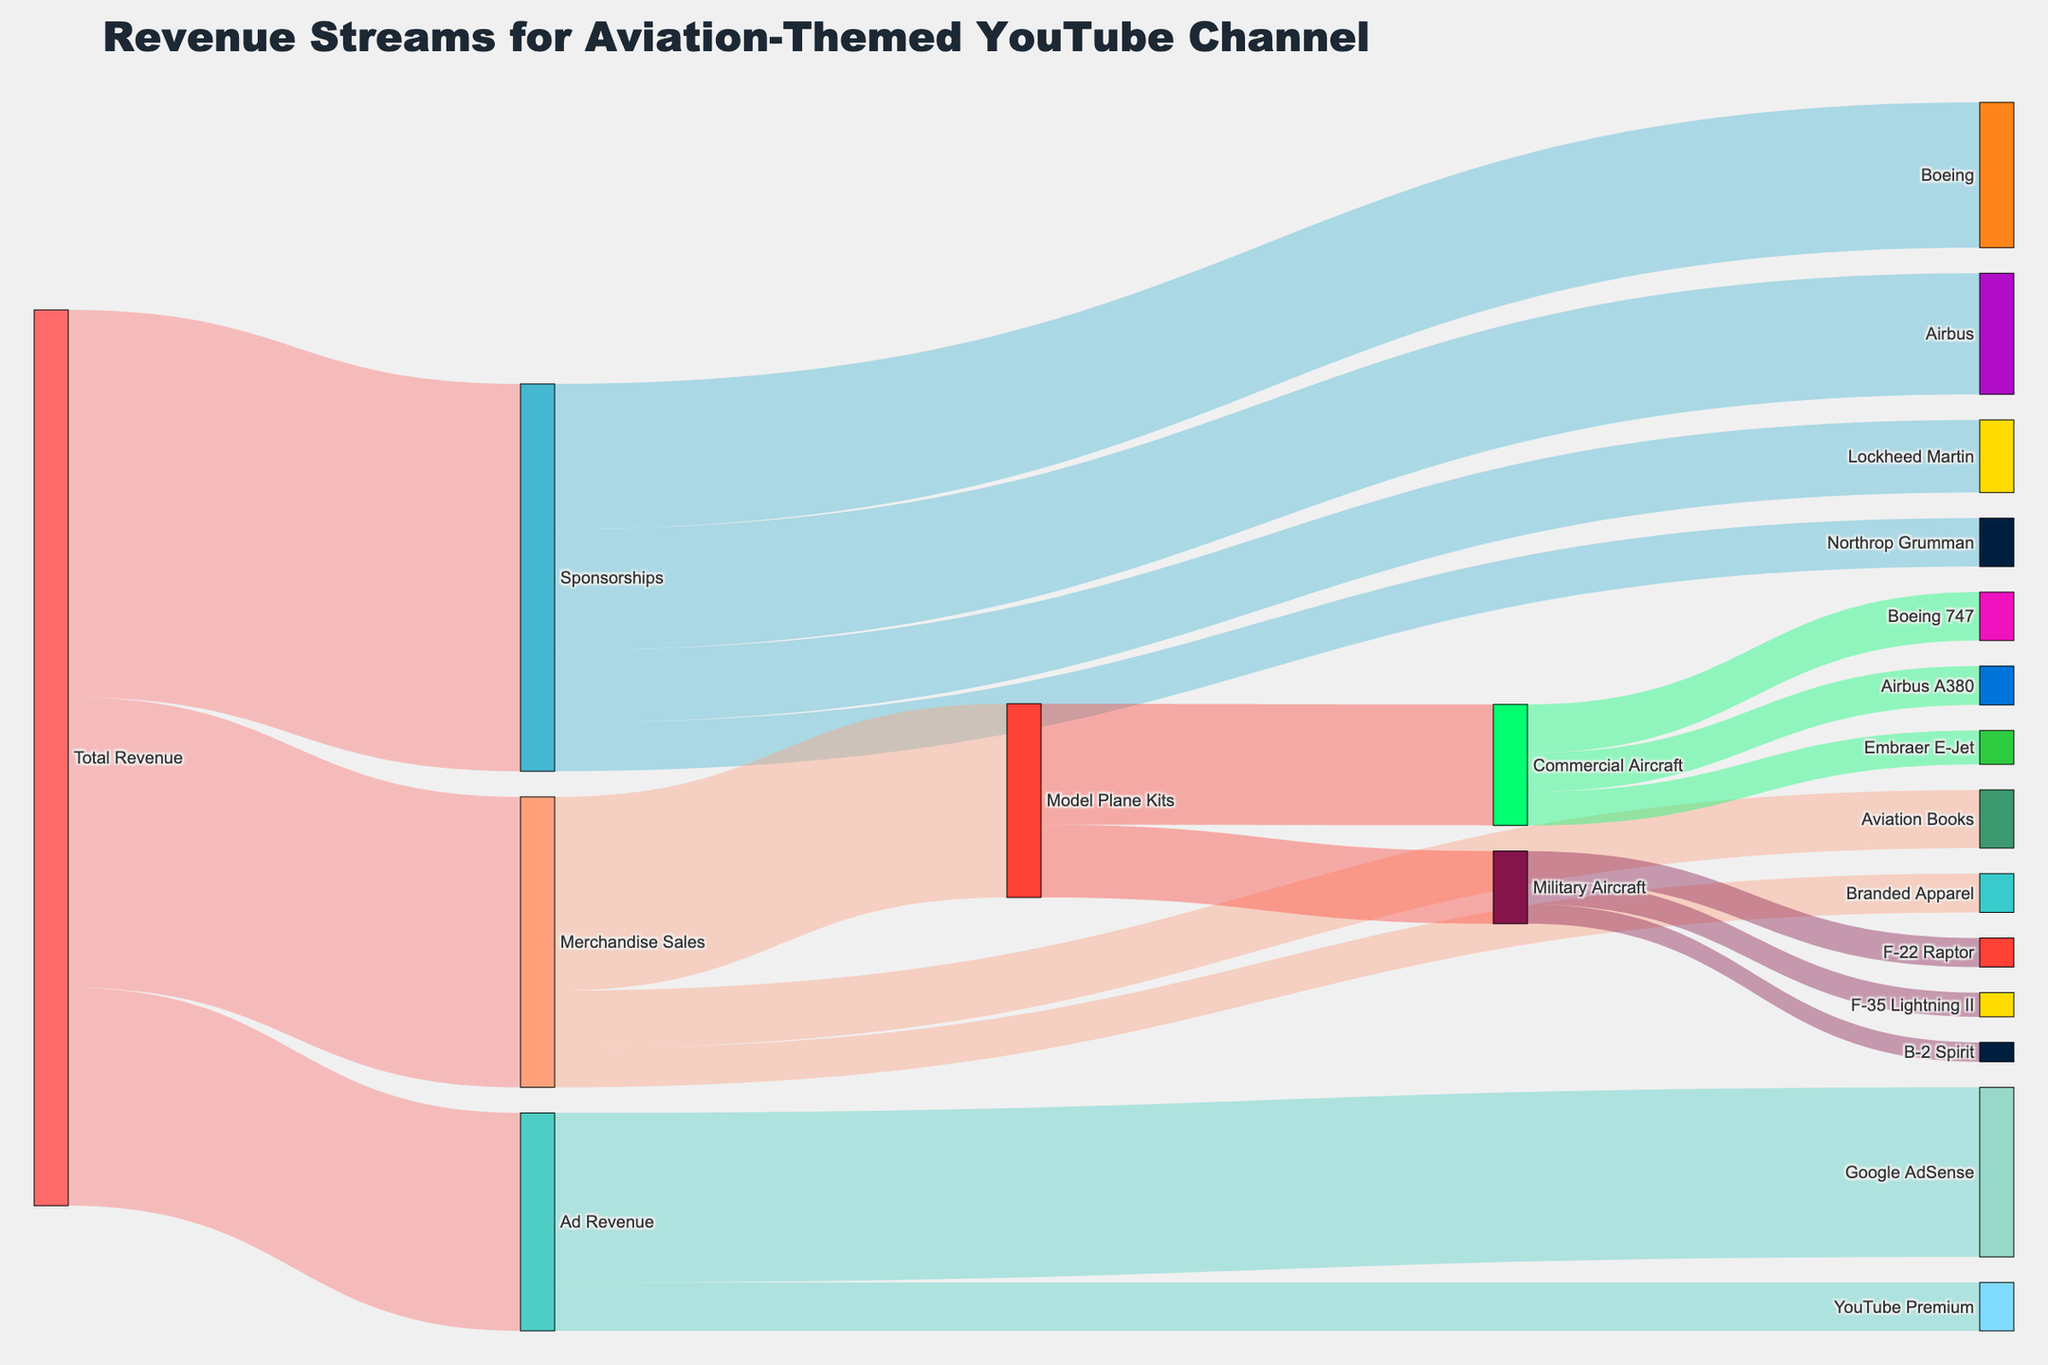What's the largest revenue stream for the aviation-themed YouTube channel? First, look at the main branches coming from "Total Revenue". Observe that "Sponsorships" has the highest value among the three branches, which is $80,000.
Answer: Sponsorships How much revenue is generated from Model Plane Kits? Follow the path from "Total Revenue" to "Merchandise Sales" and then to "Model Plane Kits". The value shown for "Model Plane Kits" is $40,000.
Answer: $40,000 Which sponsorship contributes the least to the total revenue? From the "Sponsorships" branch, identify the sponsor with the smallest contribution. Northrop Grumman at $10,000 is the smallest.
Answer: Northrop Grumman What's the combined revenue from Boeing and Airbus sponsorships? Sum the values from "Boeing" ($30,000) and "Airbus" ($25,000). The total is $30,000 + $25,000 = $55,000.
Answer: $55,000 How much revenue is generated from Ad Revenue? Look at the value stemming from "Total Revenue" towards "Ad Revenue". The value is $45,000.
Answer: $45,000 Compare the revenues from Commercial Aircraft and Military Aircraft model plane kits. Which one is higher and by how much? From "Model Plane Kits", observe the paths to "Commercial Aircraft" ($25,000) and "Military Aircraft" ($15,000). Calculate the difference: $25,000 - $15,000 = $10,000. Thus, Commercial Aircraft is higher by $10,000.
Answer: Commercial Aircraft by $10,000 What is the total revenue from YouTube-related sources? Add the values from "Ad Revenue" branches: $35,000 (Google AdSense) + $10,000 (YouTube Premium) = $45,000.
Answer: $45,000 How does the revenue from Aviation Books compare to Branded Apparel? Check the values under "Merchandise Sales". Aviation Books contribute $12,000, while Branded Apparel contributes $8,000. $12,000 is greater than $8,000.
Answer: Aviation Books is higher What percentage of Merchandise Sales come from Model Plane Kits? Divide the Model Plane Kits revenue ($40,000) by the total Merchandise Sales ($60,000) and multiply by 100: ($40,000 / $60,000) * 100 = 66.67%.
Answer: 66.67% Which has a higher revenue contribution, YouTube Premium or Lockheed Martin? YouTube Premium contributes $10,000 while Lockheed Martin contributes $15,000. $15,000 is greater than $10,000.
Answer: Lockheed Martin 